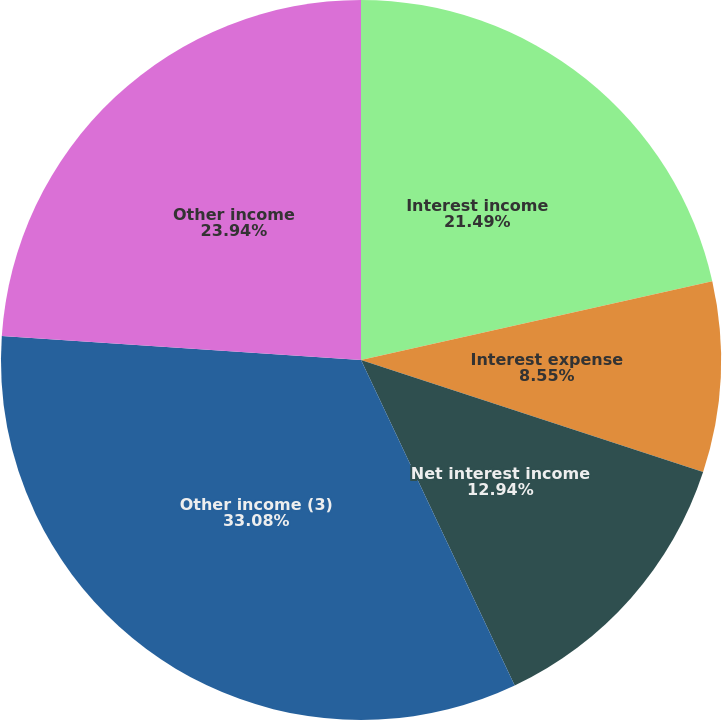Convert chart to OTSL. <chart><loc_0><loc_0><loc_500><loc_500><pie_chart><fcel>Interest income<fcel>Interest expense<fcel>Net interest income<fcel>Other income (3)<fcel>Other income<nl><fcel>21.49%<fcel>8.55%<fcel>12.94%<fcel>33.08%<fcel>23.94%<nl></chart> 